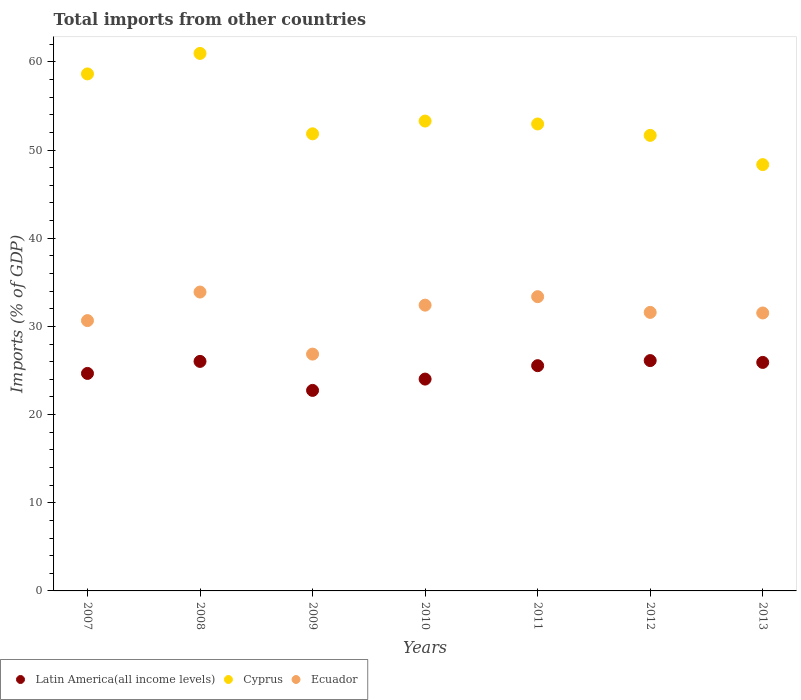How many different coloured dotlines are there?
Your answer should be compact. 3. Is the number of dotlines equal to the number of legend labels?
Your answer should be compact. Yes. What is the total imports in Ecuador in 2013?
Provide a succinct answer. 31.52. Across all years, what is the maximum total imports in Cyprus?
Offer a terse response. 60.95. Across all years, what is the minimum total imports in Latin America(all income levels)?
Keep it short and to the point. 22.74. In which year was the total imports in Ecuador maximum?
Offer a terse response. 2008. What is the total total imports in Cyprus in the graph?
Provide a succinct answer. 377.67. What is the difference between the total imports in Ecuador in 2010 and that in 2012?
Provide a succinct answer. 0.82. What is the difference between the total imports in Cyprus in 2009 and the total imports in Ecuador in 2012?
Provide a short and direct response. 20.25. What is the average total imports in Latin America(all income levels) per year?
Make the answer very short. 25.01. In the year 2009, what is the difference between the total imports in Latin America(all income levels) and total imports in Ecuador?
Your response must be concise. -4.12. In how many years, is the total imports in Cyprus greater than 32 %?
Offer a very short reply. 7. What is the ratio of the total imports in Cyprus in 2007 to that in 2010?
Make the answer very short. 1.1. What is the difference between the highest and the second highest total imports in Latin America(all income levels)?
Your answer should be compact. 0.09. What is the difference between the highest and the lowest total imports in Ecuador?
Make the answer very short. 7.04. In how many years, is the total imports in Ecuador greater than the average total imports in Ecuador taken over all years?
Your response must be concise. 5. Is the sum of the total imports in Ecuador in 2008 and 2011 greater than the maximum total imports in Cyprus across all years?
Your answer should be compact. Yes. Is the total imports in Ecuador strictly greater than the total imports in Latin America(all income levels) over the years?
Keep it short and to the point. Yes. What is the difference between two consecutive major ticks on the Y-axis?
Your answer should be compact. 10. Are the values on the major ticks of Y-axis written in scientific E-notation?
Give a very brief answer. No. How are the legend labels stacked?
Offer a very short reply. Horizontal. What is the title of the graph?
Ensure brevity in your answer.  Total imports from other countries. Does "Madagascar" appear as one of the legend labels in the graph?
Keep it short and to the point. No. What is the label or title of the X-axis?
Offer a very short reply. Years. What is the label or title of the Y-axis?
Make the answer very short. Imports (% of GDP). What is the Imports (% of GDP) of Latin America(all income levels) in 2007?
Offer a terse response. 24.67. What is the Imports (% of GDP) in Cyprus in 2007?
Make the answer very short. 58.63. What is the Imports (% of GDP) of Ecuador in 2007?
Provide a succinct answer. 30.66. What is the Imports (% of GDP) in Latin America(all income levels) in 2008?
Offer a terse response. 26.03. What is the Imports (% of GDP) of Cyprus in 2008?
Your answer should be very brief. 60.95. What is the Imports (% of GDP) in Ecuador in 2008?
Provide a short and direct response. 33.89. What is the Imports (% of GDP) of Latin America(all income levels) in 2009?
Keep it short and to the point. 22.74. What is the Imports (% of GDP) in Cyprus in 2009?
Ensure brevity in your answer.  51.84. What is the Imports (% of GDP) in Ecuador in 2009?
Make the answer very short. 26.86. What is the Imports (% of GDP) of Latin America(all income levels) in 2010?
Give a very brief answer. 24.02. What is the Imports (% of GDP) in Cyprus in 2010?
Your answer should be very brief. 53.28. What is the Imports (% of GDP) of Ecuador in 2010?
Give a very brief answer. 32.41. What is the Imports (% of GDP) of Latin America(all income levels) in 2011?
Your answer should be compact. 25.54. What is the Imports (% of GDP) in Cyprus in 2011?
Your answer should be very brief. 52.95. What is the Imports (% of GDP) in Ecuador in 2011?
Offer a terse response. 33.37. What is the Imports (% of GDP) in Latin America(all income levels) in 2012?
Your response must be concise. 26.12. What is the Imports (% of GDP) in Cyprus in 2012?
Offer a very short reply. 51.66. What is the Imports (% of GDP) of Ecuador in 2012?
Your answer should be very brief. 31.59. What is the Imports (% of GDP) of Latin America(all income levels) in 2013?
Give a very brief answer. 25.91. What is the Imports (% of GDP) in Cyprus in 2013?
Provide a short and direct response. 48.35. What is the Imports (% of GDP) in Ecuador in 2013?
Your response must be concise. 31.52. Across all years, what is the maximum Imports (% of GDP) in Latin America(all income levels)?
Offer a terse response. 26.12. Across all years, what is the maximum Imports (% of GDP) of Cyprus?
Offer a very short reply. 60.95. Across all years, what is the maximum Imports (% of GDP) in Ecuador?
Offer a very short reply. 33.89. Across all years, what is the minimum Imports (% of GDP) in Latin America(all income levels)?
Offer a very short reply. 22.74. Across all years, what is the minimum Imports (% of GDP) in Cyprus?
Offer a very short reply. 48.35. Across all years, what is the minimum Imports (% of GDP) of Ecuador?
Ensure brevity in your answer.  26.86. What is the total Imports (% of GDP) of Latin America(all income levels) in the graph?
Your response must be concise. 175.04. What is the total Imports (% of GDP) in Cyprus in the graph?
Give a very brief answer. 377.67. What is the total Imports (% of GDP) of Ecuador in the graph?
Keep it short and to the point. 220.29. What is the difference between the Imports (% of GDP) of Latin America(all income levels) in 2007 and that in 2008?
Make the answer very short. -1.36. What is the difference between the Imports (% of GDP) in Cyprus in 2007 and that in 2008?
Your response must be concise. -2.32. What is the difference between the Imports (% of GDP) of Ecuador in 2007 and that in 2008?
Provide a short and direct response. -3.24. What is the difference between the Imports (% of GDP) in Latin America(all income levels) in 2007 and that in 2009?
Offer a very short reply. 1.93. What is the difference between the Imports (% of GDP) in Cyprus in 2007 and that in 2009?
Offer a very short reply. 6.79. What is the difference between the Imports (% of GDP) of Ecuador in 2007 and that in 2009?
Give a very brief answer. 3.8. What is the difference between the Imports (% of GDP) in Latin America(all income levels) in 2007 and that in 2010?
Provide a succinct answer. 0.64. What is the difference between the Imports (% of GDP) in Cyprus in 2007 and that in 2010?
Keep it short and to the point. 5.35. What is the difference between the Imports (% of GDP) in Ecuador in 2007 and that in 2010?
Make the answer very short. -1.75. What is the difference between the Imports (% of GDP) of Latin America(all income levels) in 2007 and that in 2011?
Your answer should be compact. -0.88. What is the difference between the Imports (% of GDP) in Cyprus in 2007 and that in 2011?
Keep it short and to the point. 5.68. What is the difference between the Imports (% of GDP) of Ecuador in 2007 and that in 2011?
Offer a very short reply. -2.71. What is the difference between the Imports (% of GDP) of Latin America(all income levels) in 2007 and that in 2012?
Offer a very short reply. -1.46. What is the difference between the Imports (% of GDP) in Cyprus in 2007 and that in 2012?
Your response must be concise. 6.97. What is the difference between the Imports (% of GDP) in Ecuador in 2007 and that in 2012?
Offer a very short reply. -0.93. What is the difference between the Imports (% of GDP) in Latin America(all income levels) in 2007 and that in 2013?
Keep it short and to the point. -1.25. What is the difference between the Imports (% of GDP) of Cyprus in 2007 and that in 2013?
Offer a terse response. 10.29. What is the difference between the Imports (% of GDP) of Ecuador in 2007 and that in 2013?
Provide a short and direct response. -0.87. What is the difference between the Imports (% of GDP) of Latin America(all income levels) in 2008 and that in 2009?
Offer a terse response. 3.29. What is the difference between the Imports (% of GDP) of Cyprus in 2008 and that in 2009?
Give a very brief answer. 9.12. What is the difference between the Imports (% of GDP) of Ecuador in 2008 and that in 2009?
Your response must be concise. 7.04. What is the difference between the Imports (% of GDP) of Latin America(all income levels) in 2008 and that in 2010?
Your response must be concise. 2.01. What is the difference between the Imports (% of GDP) in Cyprus in 2008 and that in 2010?
Offer a terse response. 7.67. What is the difference between the Imports (% of GDP) in Ecuador in 2008 and that in 2010?
Your response must be concise. 1.49. What is the difference between the Imports (% of GDP) of Latin America(all income levels) in 2008 and that in 2011?
Your response must be concise. 0.48. What is the difference between the Imports (% of GDP) of Cyprus in 2008 and that in 2011?
Provide a short and direct response. 8. What is the difference between the Imports (% of GDP) of Ecuador in 2008 and that in 2011?
Ensure brevity in your answer.  0.52. What is the difference between the Imports (% of GDP) of Latin America(all income levels) in 2008 and that in 2012?
Provide a succinct answer. -0.09. What is the difference between the Imports (% of GDP) in Cyprus in 2008 and that in 2012?
Ensure brevity in your answer.  9.29. What is the difference between the Imports (% of GDP) of Ecuador in 2008 and that in 2012?
Your response must be concise. 2.31. What is the difference between the Imports (% of GDP) of Latin America(all income levels) in 2008 and that in 2013?
Your answer should be very brief. 0.12. What is the difference between the Imports (% of GDP) in Cyprus in 2008 and that in 2013?
Your answer should be compact. 12.61. What is the difference between the Imports (% of GDP) of Ecuador in 2008 and that in 2013?
Your answer should be very brief. 2.37. What is the difference between the Imports (% of GDP) in Latin America(all income levels) in 2009 and that in 2010?
Your answer should be compact. -1.28. What is the difference between the Imports (% of GDP) of Cyprus in 2009 and that in 2010?
Offer a very short reply. -1.45. What is the difference between the Imports (% of GDP) in Ecuador in 2009 and that in 2010?
Provide a short and direct response. -5.55. What is the difference between the Imports (% of GDP) of Latin America(all income levels) in 2009 and that in 2011?
Provide a succinct answer. -2.8. What is the difference between the Imports (% of GDP) of Cyprus in 2009 and that in 2011?
Make the answer very short. -1.12. What is the difference between the Imports (% of GDP) in Ecuador in 2009 and that in 2011?
Give a very brief answer. -6.51. What is the difference between the Imports (% of GDP) in Latin America(all income levels) in 2009 and that in 2012?
Your response must be concise. -3.38. What is the difference between the Imports (% of GDP) of Cyprus in 2009 and that in 2012?
Your answer should be compact. 0.18. What is the difference between the Imports (% of GDP) in Ecuador in 2009 and that in 2012?
Provide a succinct answer. -4.73. What is the difference between the Imports (% of GDP) in Latin America(all income levels) in 2009 and that in 2013?
Give a very brief answer. -3.17. What is the difference between the Imports (% of GDP) of Cyprus in 2009 and that in 2013?
Your answer should be very brief. 3.49. What is the difference between the Imports (% of GDP) in Ecuador in 2009 and that in 2013?
Your answer should be compact. -4.66. What is the difference between the Imports (% of GDP) of Latin America(all income levels) in 2010 and that in 2011?
Provide a short and direct response. -1.52. What is the difference between the Imports (% of GDP) in Cyprus in 2010 and that in 2011?
Offer a terse response. 0.33. What is the difference between the Imports (% of GDP) of Ecuador in 2010 and that in 2011?
Your answer should be compact. -0.96. What is the difference between the Imports (% of GDP) in Latin America(all income levels) in 2010 and that in 2012?
Provide a succinct answer. -2.1. What is the difference between the Imports (% of GDP) of Cyprus in 2010 and that in 2012?
Offer a very short reply. 1.62. What is the difference between the Imports (% of GDP) of Ecuador in 2010 and that in 2012?
Offer a very short reply. 0.82. What is the difference between the Imports (% of GDP) in Latin America(all income levels) in 2010 and that in 2013?
Offer a very short reply. -1.89. What is the difference between the Imports (% of GDP) in Cyprus in 2010 and that in 2013?
Ensure brevity in your answer.  4.94. What is the difference between the Imports (% of GDP) in Ecuador in 2010 and that in 2013?
Provide a short and direct response. 0.89. What is the difference between the Imports (% of GDP) of Latin America(all income levels) in 2011 and that in 2012?
Your answer should be very brief. -0.58. What is the difference between the Imports (% of GDP) in Cyprus in 2011 and that in 2012?
Keep it short and to the point. 1.29. What is the difference between the Imports (% of GDP) in Ecuador in 2011 and that in 2012?
Give a very brief answer. 1.78. What is the difference between the Imports (% of GDP) in Latin America(all income levels) in 2011 and that in 2013?
Make the answer very short. -0.37. What is the difference between the Imports (% of GDP) in Cyprus in 2011 and that in 2013?
Provide a succinct answer. 4.61. What is the difference between the Imports (% of GDP) of Ecuador in 2011 and that in 2013?
Give a very brief answer. 1.85. What is the difference between the Imports (% of GDP) of Latin America(all income levels) in 2012 and that in 2013?
Make the answer very short. 0.21. What is the difference between the Imports (% of GDP) in Cyprus in 2012 and that in 2013?
Give a very brief answer. 3.32. What is the difference between the Imports (% of GDP) of Ecuador in 2012 and that in 2013?
Your answer should be compact. 0.07. What is the difference between the Imports (% of GDP) in Latin America(all income levels) in 2007 and the Imports (% of GDP) in Cyprus in 2008?
Keep it short and to the point. -36.29. What is the difference between the Imports (% of GDP) of Latin America(all income levels) in 2007 and the Imports (% of GDP) of Ecuador in 2008?
Ensure brevity in your answer.  -9.23. What is the difference between the Imports (% of GDP) in Cyprus in 2007 and the Imports (% of GDP) in Ecuador in 2008?
Your answer should be compact. 24.74. What is the difference between the Imports (% of GDP) in Latin America(all income levels) in 2007 and the Imports (% of GDP) in Cyprus in 2009?
Your response must be concise. -27.17. What is the difference between the Imports (% of GDP) in Latin America(all income levels) in 2007 and the Imports (% of GDP) in Ecuador in 2009?
Make the answer very short. -2.19. What is the difference between the Imports (% of GDP) in Cyprus in 2007 and the Imports (% of GDP) in Ecuador in 2009?
Make the answer very short. 31.78. What is the difference between the Imports (% of GDP) in Latin America(all income levels) in 2007 and the Imports (% of GDP) in Cyprus in 2010?
Provide a short and direct response. -28.62. What is the difference between the Imports (% of GDP) of Latin America(all income levels) in 2007 and the Imports (% of GDP) of Ecuador in 2010?
Give a very brief answer. -7.74. What is the difference between the Imports (% of GDP) in Cyprus in 2007 and the Imports (% of GDP) in Ecuador in 2010?
Your response must be concise. 26.22. What is the difference between the Imports (% of GDP) in Latin America(all income levels) in 2007 and the Imports (% of GDP) in Cyprus in 2011?
Your response must be concise. -28.29. What is the difference between the Imports (% of GDP) in Latin America(all income levels) in 2007 and the Imports (% of GDP) in Ecuador in 2011?
Your answer should be very brief. -8.7. What is the difference between the Imports (% of GDP) in Cyprus in 2007 and the Imports (% of GDP) in Ecuador in 2011?
Your answer should be compact. 25.26. What is the difference between the Imports (% of GDP) in Latin America(all income levels) in 2007 and the Imports (% of GDP) in Cyprus in 2012?
Give a very brief answer. -27. What is the difference between the Imports (% of GDP) of Latin America(all income levels) in 2007 and the Imports (% of GDP) of Ecuador in 2012?
Offer a very short reply. -6.92. What is the difference between the Imports (% of GDP) of Cyprus in 2007 and the Imports (% of GDP) of Ecuador in 2012?
Keep it short and to the point. 27.05. What is the difference between the Imports (% of GDP) in Latin America(all income levels) in 2007 and the Imports (% of GDP) in Cyprus in 2013?
Provide a succinct answer. -23.68. What is the difference between the Imports (% of GDP) of Latin America(all income levels) in 2007 and the Imports (% of GDP) of Ecuador in 2013?
Ensure brevity in your answer.  -6.86. What is the difference between the Imports (% of GDP) of Cyprus in 2007 and the Imports (% of GDP) of Ecuador in 2013?
Make the answer very short. 27.11. What is the difference between the Imports (% of GDP) of Latin America(all income levels) in 2008 and the Imports (% of GDP) of Cyprus in 2009?
Keep it short and to the point. -25.81. What is the difference between the Imports (% of GDP) of Latin America(all income levels) in 2008 and the Imports (% of GDP) of Ecuador in 2009?
Offer a very short reply. -0.83. What is the difference between the Imports (% of GDP) of Cyprus in 2008 and the Imports (% of GDP) of Ecuador in 2009?
Your response must be concise. 34.1. What is the difference between the Imports (% of GDP) in Latin America(all income levels) in 2008 and the Imports (% of GDP) in Cyprus in 2010?
Your answer should be compact. -27.26. What is the difference between the Imports (% of GDP) of Latin America(all income levels) in 2008 and the Imports (% of GDP) of Ecuador in 2010?
Provide a short and direct response. -6.38. What is the difference between the Imports (% of GDP) in Cyprus in 2008 and the Imports (% of GDP) in Ecuador in 2010?
Give a very brief answer. 28.55. What is the difference between the Imports (% of GDP) in Latin America(all income levels) in 2008 and the Imports (% of GDP) in Cyprus in 2011?
Ensure brevity in your answer.  -26.93. What is the difference between the Imports (% of GDP) in Latin America(all income levels) in 2008 and the Imports (% of GDP) in Ecuador in 2011?
Ensure brevity in your answer.  -7.34. What is the difference between the Imports (% of GDP) of Cyprus in 2008 and the Imports (% of GDP) of Ecuador in 2011?
Offer a terse response. 27.59. What is the difference between the Imports (% of GDP) in Latin America(all income levels) in 2008 and the Imports (% of GDP) in Cyprus in 2012?
Your answer should be compact. -25.63. What is the difference between the Imports (% of GDP) in Latin America(all income levels) in 2008 and the Imports (% of GDP) in Ecuador in 2012?
Your answer should be very brief. -5.56. What is the difference between the Imports (% of GDP) in Cyprus in 2008 and the Imports (% of GDP) in Ecuador in 2012?
Your response must be concise. 29.37. What is the difference between the Imports (% of GDP) in Latin America(all income levels) in 2008 and the Imports (% of GDP) in Cyprus in 2013?
Your answer should be compact. -22.32. What is the difference between the Imports (% of GDP) of Latin America(all income levels) in 2008 and the Imports (% of GDP) of Ecuador in 2013?
Provide a succinct answer. -5.49. What is the difference between the Imports (% of GDP) of Cyprus in 2008 and the Imports (% of GDP) of Ecuador in 2013?
Your response must be concise. 29.43. What is the difference between the Imports (% of GDP) of Latin America(all income levels) in 2009 and the Imports (% of GDP) of Cyprus in 2010?
Your answer should be very brief. -30.54. What is the difference between the Imports (% of GDP) in Latin America(all income levels) in 2009 and the Imports (% of GDP) in Ecuador in 2010?
Your answer should be compact. -9.67. What is the difference between the Imports (% of GDP) in Cyprus in 2009 and the Imports (% of GDP) in Ecuador in 2010?
Make the answer very short. 19.43. What is the difference between the Imports (% of GDP) in Latin America(all income levels) in 2009 and the Imports (% of GDP) in Cyprus in 2011?
Provide a succinct answer. -30.21. What is the difference between the Imports (% of GDP) in Latin America(all income levels) in 2009 and the Imports (% of GDP) in Ecuador in 2011?
Make the answer very short. -10.63. What is the difference between the Imports (% of GDP) in Cyprus in 2009 and the Imports (% of GDP) in Ecuador in 2011?
Offer a terse response. 18.47. What is the difference between the Imports (% of GDP) in Latin America(all income levels) in 2009 and the Imports (% of GDP) in Cyprus in 2012?
Your response must be concise. -28.92. What is the difference between the Imports (% of GDP) of Latin America(all income levels) in 2009 and the Imports (% of GDP) of Ecuador in 2012?
Offer a very short reply. -8.85. What is the difference between the Imports (% of GDP) in Cyprus in 2009 and the Imports (% of GDP) in Ecuador in 2012?
Your answer should be compact. 20.25. What is the difference between the Imports (% of GDP) in Latin America(all income levels) in 2009 and the Imports (% of GDP) in Cyprus in 2013?
Make the answer very short. -25.61. What is the difference between the Imports (% of GDP) of Latin America(all income levels) in 2009 and the Imports (% of GDP) of Ecuador in 2013?
Provide a short and direct response. -8.78. What is the difference between the Imports (% of GDP) of Cyprus in 2009 and the Imports (% of GDP) of Ecuador in 2013?
Provide a succinct answer. 20.32. What is the difference between the Imports (% of GDP) of Latin America(all income levels) in 2010 and the Imports (% of GDP) of Cyprus in 2011?
Offer a terse response. -28.93. What is the difference between the Imports (% of GDP) of Latin America(all income levels) in 2010 and the Imports (% of GDP) of Ecuador in 2011?
Keep it short and to the point. -9.35. What is the difference between the Imports (% of GDP) of Cyprus in 2010 and the Imports (% of GDP) of Ecuador in 2011?
Give a very brief answer. 19.92. What is the difference between the Imports (% of GDP) of Latin America(all income levels) in 2010 and the Imports (% of GDP) of Cyprus in 2012?
Make the answer very short. -27.64. What is the difference between the Imports (% of GDP) in Latin America(all income levels) in 2010 and the Imports (% of GDP) in Ecuador in 2012?
Ensure brevity in your answer.  -7.56. What is the difference between the Imports (% of GDP) of Cyprus in 2010 and the Imports (% of GDP) of Ecuador in 2012?
Keep it short and to the point. 21.7. What is the difference between the Imports (% of GDP) of Latin America(all income levels) in 2010 and the Imports (% of GDP) of Cyprus in 2013?
Make the answer very short. -24.32. What is the difference between the Imports (% of GDP) of Latin America(all income levels) in 2010 and the Imports (% of GDP) of Ecuador in 2013?
Provide a succinct answer. -7.5. What is the difference between the Imports (% of GDP) in Cyprus in 2010 and the Imports (% of GDP) in Ecuador in 2013?
Your response must be concise. 21.76. What is the difference between the Imports (% of GDP) in Latin America(all income levels) in 2011 and the Imports (% of GDP) in Cyprus in 2012?
Your answer should be compact. -26.12. What is the difference between the Imports (% of GDP) of Latin America(all income levels) in 2011 and the Imports (% of GDP) of Ecuador in 2012?
Offer a terse response. -6.04. What is the difference between the Imports (% of GDP) in Cyprus in 2011 and the Imports (% of GDP) in Ecuador in 2012?
Give a very brief answer. 21.37. What is the difference between the Imports (% of GDP) in Latin America(all income levels) in 2011 and the Imports (% of GDP) in Cyprus in 2013?
Give a very brief answer. -22.8. What is the difference between the Imports (% of GDP) in Latin America(all income levels) in 2011 and the Imports (% of GDP) in Ecuador in 2013?
Your response must be concise. -5.98. What is the difference between the Imports (% of GDP) of Cyprus in 2011 and the Imports (% of GDP) of Ecuador in 2013?
Keep it short and to the point. 21.43. What is the difference between the Imports (% of GDP) in Latin America(all income levels) in 2012 and the Imports (% of GDP) in Cyprus in 2013?
Your response must be concise. -22.22. What is the difference between the Imports (% of GDP) of Latin America(all income levels) in 2012 and the Imports (% of GDP) of Ecuador in 2013?
Offer a terse response. -5.4. What is the difference between the Imports (% of GDP) in Cyprus in 2012 and the Imports (% of GDP) in Ecuador in 2013?
Your answer should be very brief. 20.14. What is the average Imports (% of GDP) in Latin America(all income levels) per year?
Your response must be concise. 25.01. What is the average Imports (% of GDP) of Cyprus per year?
Offer a terse response. 53.95. What is the average Imports (% of GDP) of Ecuador per year?
Offer a very short reply. 31.47. In the year 2007, what is the difference between the Imports (% of GDP) in Latin America(all income levels) and Imports (% of GDP) in Cyprus?
Your answer should be compact. -33.97. In the year 2007, what is the difference between the Imports (% of GDP) in Latin America(all income levels) and Imports (% of GDP) in Ecuador?
Provide a succinct answer. -5.99. In the year 2007, what is the difference between the Imports (% of GDP) of Cyprus and Imports (% of GDP) of Ecuador?
Provide a short and direct response. 27.98. In the year 2008, what is the difference between the Imports (% of GDP) in Latin America(all income levels) and Imports (% of GDP) in Cyprus?
Give a very brief answer. -34.93. In the year 2008, what is the difference between the Imports (% of GDP) in Latin America(all income levels) and Imports (% of GDP) in Ecuador?
Ensure brevity in your answer.  -7.86. In the year 2008, what is the difference between the Imports (% of GDP) in Cyprus and Imports (% of GDP) in Ecuador?
Make the answer very short. 27.06. In the year 2009, what is the difference between the Imports (% of GDP) in Latin America(all income levels) and Imports (% of GDP) in Cyprus?
Keep it short and to the point. -29.1. In the year 2009, what is the difference between the Imports (% of GDP) of Latin America(all income levels) and Imports (% of GDP) of Ecuador?
Ensure brevity in your answer.  -4.12. In the year 2009, what is the difference between the Imports (% of GDP) of Cyprus and Imports (% of GDP) of Ecuador?
Provide a short and direct response. 24.98. In the year 2010, what is the difference between the Imports (% of GDP) in Latin America(all income levels) and Imports (% of GDP) in Cyprus?
Give a very brief answer. -29.26. In the year 2010, what is the difference between the Imports (% of GDP) of Latin America(all income levels) and Imports (% of GDP) of Ecuador?
Provide a short and direct response. -8.38. In the year 2010, what is the difference between the Imports (% of GDP) of Cyprus and Imports (% of GDP) of Ecuador?
Provide a short and direct response. 20.88. In the year 2011, what is the difference between the Imports (% of GDP) of Latin America(all income levels) and Imports (% of GDP) of Cyprus?
Ensure brevity in your answer.  -27.41. In the year 2011, what is the difference between the Imports (% of GDP) of Latin America(all income levels) and Imports (% of GDP) of Ecuador?
Provide a short and direct response. -7.83. In the year 2011, what is the difference between the Imports (% of GDP) of Cyprus and Imports (% of GDP) of Ecuador?
Ensure brevity in your answer.  19.59. In the year 2012, what is the difference between the Imports (% of GDP) in Latin America(all income levels) and Imports (% of GDP) in Cyprus?
Offer a terse response. -25.54. In the year 2012, what is the difference between the Imports (% of GDP) in Latin America(all income levels) and Imports (% of GDP) in Ecuador?
Ensure brevity in your answer.  -5.47. In the year 2012, what is the difference between the Imports (% of GDP) of Cyprus and Imports (% of GDP) of Ecuador?
Offer a terse response. 20.08. In the year 2013, what is the difference between the Imports (% of GDP) of Latin America(all income levels) and Imports (% of GDP) of Cyprus?
Ensure brevity in your answer.  -22.43. In the year 2013, what is the difference between the Imports (% of GDP) of Latin America(all income levels) and Imports (% of GDP) of Ecuador?
Provide a short and direct response. -5.61. In the year 2013, what is the difference between the Imports (% of GDP) of Cyprus and Imports (% of GDP) of Ecuador?
Offer a very short reply. 16.82. What is the ratio of the Imports (% of GDP) in Latin America(all income levels) in 2007 to that in 2008?
Keep it short and to the point. 0.95. What is the ratio of the Imports (% of GDP) of Cyprus in 2007 to that in 2008?
Give a very brief answer. 0.96. What is the ratio of the Imports (% of GDP) of Ecuador in 2007 to that in 2008?
Provide a short and direct response. 0.9. What is the ratio of the Imports (% of GDP) of Latin America(all income levels) in 2007 to that in 2009?
Offer a terse response. 1.08. What is the ratio of the Imports (% of GDP) of Cyprus in 2007 to that in 2009?
Your answer should be very brief. 1.13. What is the ratio of the Imports (% of GDP) of Ecuador in 2007 to that in 2009?
Your answer should be compact. 1.14. What is the ratio of the Imports (% of GDP) of Latin America(all income levels) in 2007 to that in 2010?
Your answer should be very brief. 1.03. What is the ratio of the Imports (% of GDP) in Cyprus in 2007 to that in 2010?
Give a very brief answer. 1.1. What is the ratio of the Imports (% of GDP) of Ecuador in 2007 to that in 2010?
Your answer should be very brief. 0.95. What is the ratio of the Imports (% of GDP) of Latin America(all income levels) in 2007 to that in 2011?
Provide a short and direct response. 0.97. What is the ratio of the Imports (% of GDP) in Cyprus in 2007 to that in 2011?
Make the answer very short. 1.11. What is the ratio of the Imports (% of GDP) in Ecuador in 2007 to that in 2011?
Your response must be concise. 0.92. What is the ratio of the Imports (% of GDP) in Latin America(all income levels) in 2007 to that in 2012?
Your response must be concise. 0.94. What is the ratio of the Imports (% of GDP) in Cyprus in 2007 to that in 2012?
Keep it short and to the point. 1.13. What is the ratio of the Imports (% of GDP) of Ecuador in 2007 to that in 2012?
Your response must be concise. 0.97. What is the ratio of the Imports (% of GDP) of Latin America(all income levels) in 2007 to that in 2013?
Provide a short and direct response. 0.95. What is the ratio of the Imports (% of GDP) in Cyprus in 2007 to that in 2013?
Your answer should be compact. 1.21. What is the ratio of the Imports (% of GDP) of Ecuador in 2007 to that in 2013?
Make the answer very short. 0.97. What is the ratio of the Imports (% of GDP) in Latin America(all income levels) in 2008 to that in 2009?
Keep it short and to the point. 1.14. What is the ratio of the Imports (% of GDP) in Cyprus in 2008 to that in 2009?
Your answer should be compact. 1.18. What is the ratio of the Imports (% of GDP) in Ecuador in 2008 to that in 2009?
Provide a short and direct response. 1.26. What is the ratio of the Imports (% of GDP) in Latin America(all income levels) in 2008 to that in 2010?
Your answer should be very brief. 1.08. What is the ratio of the Imports (% of GDP) in Cyprus in 2008 to that in 2010?
Give a very brief answer. 1.14. What is the ratio of the Imports (% of GDP) of Ecuador in 2008 to that in 2010?
Provide a short and direct response. 1.05. What is the ratio of the Imports (% of GDP) of Latin America(all income levels) in 2008 to that in 2011?
Ensure brevity in your answer.  1.02. What is the ratio of the Imports (% of GDP) of Cyprus in 2008 to that in 2011?
Give a very brief answer. 1.15. What is the ratio of the Imports (% of GDP) of Ecuador in 2008 to that in 2011?
Ensure brevity in your answer.  1.02. What is the ratio of the Imports (% of GDP) in Cyprus in 2008 to that in 2012?
Give a very brief answer. 1.18. What is the ratio of the Imports (% of GDP) in Ecuador in 2008 to that in 2012?
Ensure brevity in your answer.  1.07. What is the ratio of the Imports (% of GDP) in Latin America(all income levels) in 2008 to that in 2013?
Provide a succinct answer. 1. What is the ratio of the Imports (% of GDP) in Cyprus in 2008 to that in 2013?
Ensure brevity in your answer.  1.26. What is the ratio of the Imports (% of GDP) in Ecuador in 2008 to that in 2013?
Your answer should be very brief. 1.08. What is the ratio of the Imports (% of GDP) in Latin America(all income levels) in 2009 to that in 2010?
Provide a short and direct response. 0.95. What is the ratio of the Imports (% of GDP) in Cyprus in 2009 to that in 2010?
Your response must be concise. 0.97. What is the ratio of the Imports (% of GDP) of Ecuador in 2009 to that in 2010?
Offer a very short reply. 0.83. What is the ratio of the Imports (% of GDP) in Latin America(all income levels) in 2009 to that in 2011?
Provide a succinct answer. 0.89. What is the ratio of the Imports (% of GDP) in Cyprus in 2009 to that in 2011?
Keep it short and to the point. 0.98. What is the ratio of the Imports (% of GDP) of Ecuador in 2009 to that in 2011?
Provide a short and direct response. 0.8. What is the ratio of the Imports (% of GDP) of Latin America(all income levels) in 2009 to that in 2012?
Offer a very short reply. 0.87. What is the ratio of the Imports (% of GDP) in Cyprus in 2009 to that in 2012?
Provide a succinct answer. 1. What is the ratio of the Imports (% of GDP) in Ecuador in 2009 to that in 2012?
Provide a succinct answer. 0.85. What is the ratio of the Imports (% of GDP) of Latin America(all income levels) in 2009 to that in 2013?
Offer a terse response. 0.88. What is the ratio of the Imports (% of GDP) in Cyprus in 2009 to that in 2013?
Your response must be concise. 1.07. What is the ratio of the Imports (% of GDP) in Ecuador in 2009 to that in 2013?
Offer a terse response. 0.85. What is the ratio of the Imports (% of GDP) of Latin America(all income levels) in 2010 to that in 2011?
Provide a succinct answer. 0.94. What is the ratio of the Imports (% of GDP) in Cyprus in 2010 to that in 2011?
Give a very brief answer. 1.01. What is the ratio of the Imports (% of GDP) in Ecuador in 2010 to that in 2011?
Ensure brevity in your answer.  0.97. What is the ratio of the Imports (% of GDP) of Latin America(all income levels) in 2010 to that in 2012?
Ensure brevity in your answer.  0.92. What is the ratio of the Imports (% of GDP) of Cyprus in 2010 to that in 2012?
Your answer should be very brief. 1.03. What is the ratio of the Imports (% of GDP) in Latin America(all income levels) in 2010 to that in 2013?
Your answer should be compact. 0.93. What is the ratio of the Imports (% of GDP) of Cyprus in 2010 to that in 2013?
Make the answer very short. 1.1. What is the ratio of the Imports (% of GDP) of Ecuador in 2010 to that in 2013?
Offer a terse response. 1.03. What is the ratio of the Imports (% of GDP) in Latin America(all income levels) in 2011 to that in 2012?
Keep it short and to the point. 0.98. What is the ratio of the Imports (% of GDP) in Ecuador in 2011 to that in 2012?
Offer a terse response. 1.06. What is the ratio of the Imports (% of GDP) of Latin America(all income levels) in 2011 to that in 2013?
Make the answer very short. 0.99. What is the ratio of the Imports (% of GDP) of Cyprus in 2011 to that in 2013?
Make the answer very short. 1.1. What is the ratio of the Imports (% of GDP) of Ecuador in 2011 to that in 2013?
Make the answer very short. 1.06. What is the ratio of the Imports (% of GDP) in Cyprus in 2012 to that in 2013?
Your answer should be very brief. 1.07. What is the ratio of the Imports (% of GDP) of Ecuador in 2012 to that in 2013?
Make the answer very short. 1. What is the difference between the highest and the second highest Imports (% of GDP) of Latin America(all income levels)?
Give a very brief answer. 0.09. What is the difference between the highest and the second highest Imports (% of GDP) in Cyprus?
Provide a short and direct response. 2.32. What is the difference between the highest and the second highest Imports (% of GDP) of Ecuador?
Keep it short and to the point. 0.52. What is the difference between the highest and the lowest Imports (% of GDP) of Latin America(all income levels)?
Give a very brief answer. 3.38. What is the difference between the highest and the lowest Imports (% of GDP) of Cyprus?
Offer a terse response. 12.61. What is the difference between the highest and the lowest Imports (% of GDP) in Ecuador?
Provide a succinct answer. 7.04. 